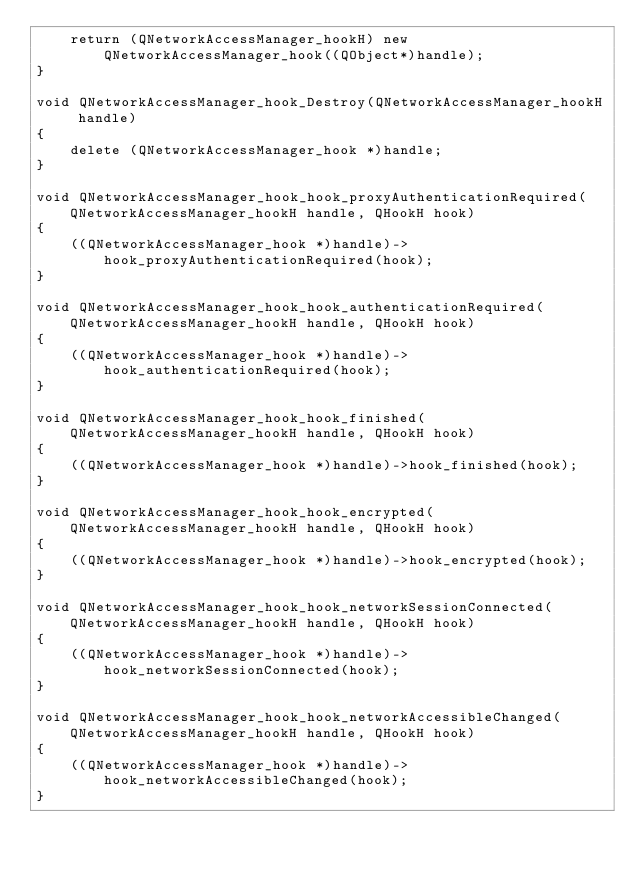Convert code to text. <code><loc_0><loc_0><loc_500><loc_500><_C++_>	return (QNetworkAccessManager_hookH) new QNetworkAccessManager_hook((QObject*)handle);
}

void QNetworkAccessManager_hook_Destroy(QNetworkAccessManager_hookH handle)
{
	delete (QNetworkAccessManager_hook *)handle;
}

void QNetworkAccessManager_hook_hook_proxyAuthenticationRequired(QNetworkAccessManager_hookH handle, QHookH hook)
{
	((QNetworkAccessManager_hook *)handle)->hook_proxyAuthenticationRequired(hook);
}

void QNetworkAccessManager_hook_hook_authenticationRequired(QNetworkAccessManager_hookH handle, QHookH hook)
{
	((QNetworkAccessManager_hook *)handle)->hook_authenticationRequired(hook);
}

void QNetworkAccessManager_hook_hook_finished(QNetworkAccessManager_hookH handle, QHookH hook)
{
	((QNetworkAccessManager_hook *)handle)->hook_finished(hook);
}

void QNetworkAccessManager_hook_hook_encrypted(QNetworkAccessManager_hookH handle, QHookH hook)
{
	((QNetworkAccessManager_hook *)handle)->hook_encrypted(hook);
}

void QNetworkAccessManager_hook_hook_networkSessionConnected(QNetworkAccessManager_hookH handle, QHookH hook)
{
	((QNetworkAccessManager_hook *)handle)->hook_networkSessionConnected(hook);
}

void QNetworkAccessManager_hook_hook_networkAccessibleChanged(QNetworkAccessManager_hookH handle, QHookH hook)
{
	((QNetworkAccessManager_hook *)handle)->hook_networkAccessibleChanged(hook);
}

</code> 